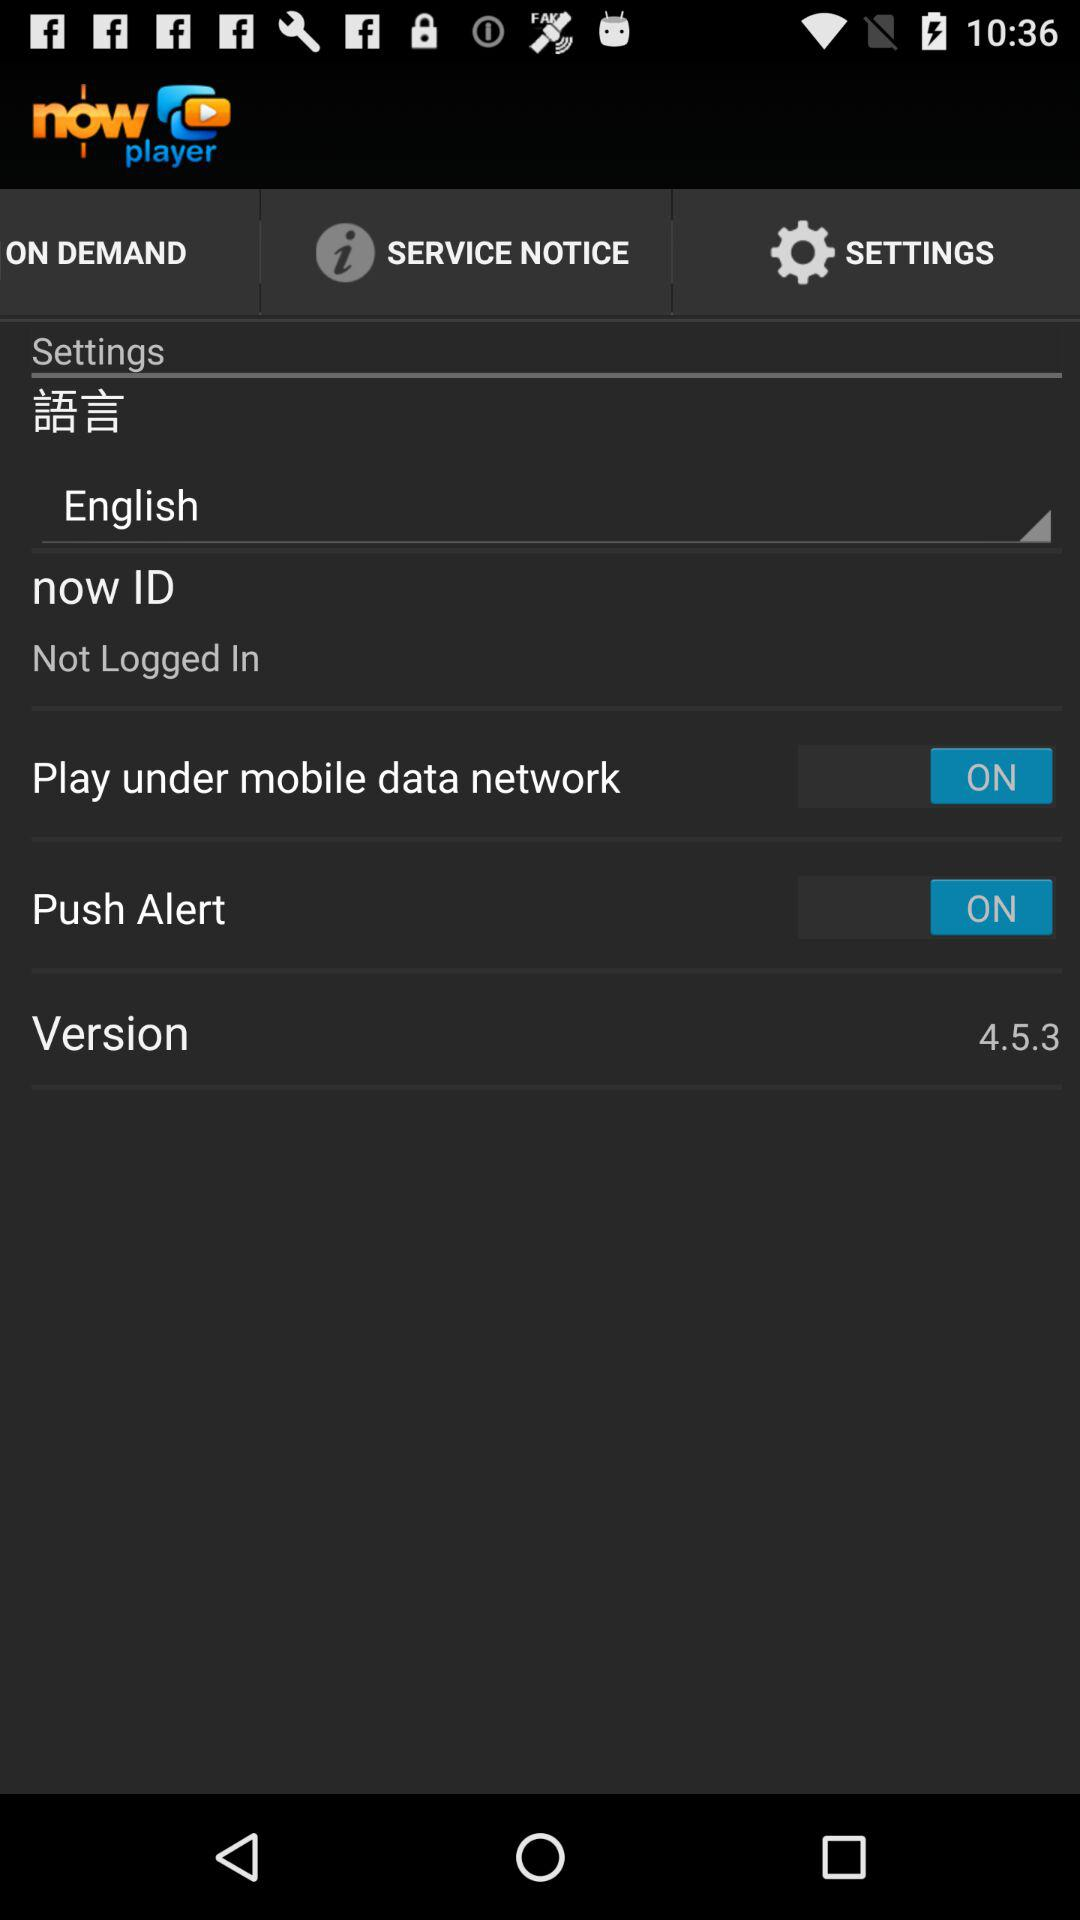What is the status of the "Push Alert"? The status of the "Push Alert" is "on". 